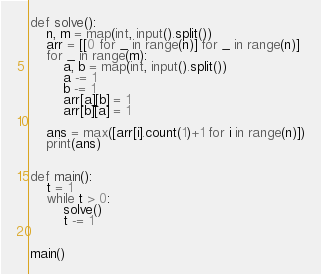<code> <loc_0><loc_0><loc_500><loc_500><_Python_>def solve():
    n, m = map(int, input().split())
    arr = [[0 for _ in range(n)] for _ in range(n)]
    for _ in range(m):
        a, b = map(int, input().split())
        a -= 1
        b -= 1
        arr[a][b] = 1
        arr[b][a] = 1

    ans = max([arr[i].count(1)+1 for i in range(n)])
    print(ans)


def main():
    t = 1
    while t > 0:
        solve()
        t -= 1


main()</code> 